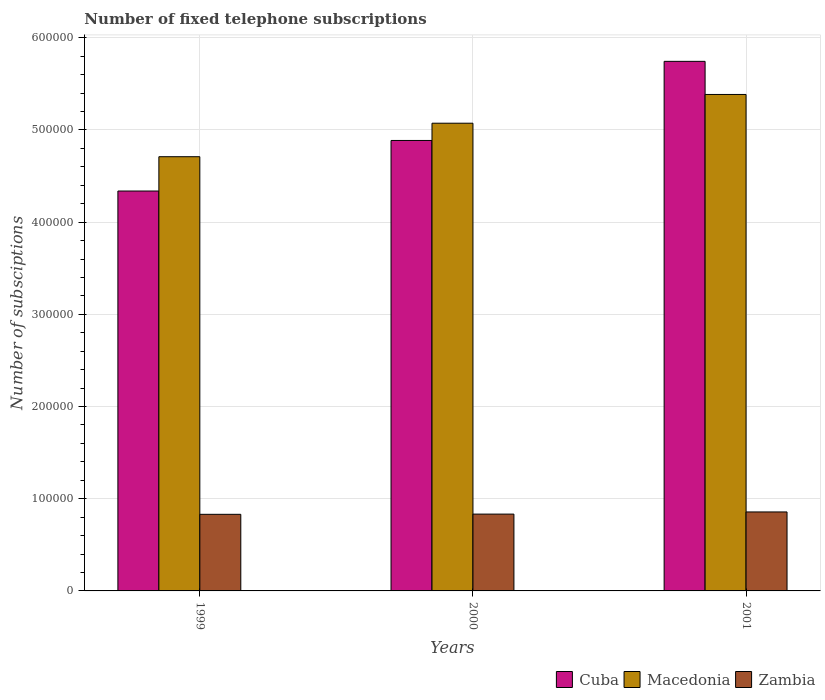Are the number of bars per tick equal to the number of legend labels?
Make the answer very short. Yes. How many bars are there on the 1st tick from the left?
Offer a very short reply. 3. What is the number of fixed telephone subscriptions in Macedonia in 2001?
Ensure brevity in your answer.  5.39e+05. Across all years, what is the maximum number of fixed telephone subscriptions in Cuba?
Provide a short and direct response. 5.74e+05. Across all years, what is the minimum number of fixed telephone subscriptions in Zambia?
Give a very brief answer. 8.31e+04. What is the total number of fixed telephone subscriptions in Macedonia in the graph?
Your answer should be very brief. 1.52e+06. What is the difference between the number of fixed telephone subscriptions in Cuba in 1999 and that in 2000?
Provide a short and direct response. -5.48e+04. What is the difference between the number of fixed telephone subscriptions in Zambia in 2000 and the number of fixed telephone subscriptions in Cuba in 2001?
Ensure brevity in your answer.  -4.91e+05. What is the average number of fixed telephone subscriptions in Zambia per year?
Offer a very short reply. 8.40e+04. In the year 2000, what is the difference between the number of fixed telephone subscriptions in Cuba and number of fixed telephone subscriptions in Macedonia?
Keep it short and to the point. -1.87e+04. What is the ratio of the number of fixed telephone subscriptions in Macedonia in 2000 to that in 2001?
Your answer should be compact. 0.94. Is the number of fixed telephone subscriptions in Cuba in 2000 less than that in 2001?
Ensure brevity in your answer.  Yes. What is the difference between the highest and the second highest number of fixed telephone subscriptions in Zambia?
Offer a very short reply. 2336. What is the difference between the highest and the lowest number of fixed telephone subscriptions in Zambia?
Your response must be concise. 2578. Is the sum of the number of fixed telephone subscriptions in Macedonia in 1999 and 2001 greater than the maximum number of fixed telephone subscriptions in Cuba across all years?
Make the answer very short. Yes. What does the 2nd bar from the left in 2001 represents?
Your answer should be very brief. Macedonia. What does the 1st bar from the right in 2001 represents?
Offer a terse response. Zambia. How many bars are there?
Offer a terse response. 9. What is the difference between two consecutive major ticks on the Y-axis?
Your answer should be compact. 1.00e+05. Does the graph contain grids?
Provide a short and direct response. Yes. How many legend labels are there?
Make the answer very short. 3. What is the title of the graph?
Your response must be concise. Number of fixed telephone subscriptions. What is the label or title of the Y-axis?
Offer a terse response. Number of subsciptions. What is the Number of subsciptions in Cuba in 1999?
Provide a succinct answer. 4.34e+05. What is the Number of subsciptions of Macedonia in 1999?
Your answer should be very brief. 4.71e+05. What is the Number of subsciptions of Zambia in 1999?
Give a very brief answer. 8.31e+04. What is the Number of subsciptions of Cuba in 2000?
Provide a short and direct response. 4.89e+05. What is the Number of subsciptions of Macedonia in 2000?
Offer a very short reply. 5.07e+05. What is the Number of subsciptions in Zambia in 2000?
Your response must be concise. 8.33e+04. What is the Number of subsciptions in Cuba in 2001?
Offer a very short reply. 5.74e+05. What is the Number of subsciptions in Macedonia in 2001?
Ensure brevity in your answer.  5.39e+05. What is the Number of subsciptions of Zambia in 2001?
Your response must be concise. 8.57e+04. Across all years, what is the maximum Number of subsciptions of Cuba?
Make the answer very short. 5.74e+05. Across all years, what is the maximum Number of subsciptions in Macedonia?
Provide a short and direct response. 5.39e+05. Across all years, what is the maximum Number of subsciptions of Zambia?
Provide a short and direct response. 8.57e+04. Across all years, what is the minimum Number of subsciptions of Cuba?
Your response must be concise. 4.34e+05. Across all years, what is the minimum Number of subsciptions of Macedonia?
Provide a short and direct response. 4.71e+05. Across all years, what is the minimum Number of subsciptions in Zambia?
Your answer should be very brief. 8.31e+04. What is the total Number of subsciptions of Cuba in the graph?
Give a very brief answer. 1.50e+06. What is the total Number of subsciptions in Macedonia in the graph?
Provide a short and direct response. 1.52e+06. What is the total Number of subsciptions in Zambia in the graph?
Provide a short and direct response. 2.52e+05. What is the difference between the Number of subsciptions in Cuba in 1999 and that in 2000?
Your answer should be very brief. -5.48e+04. What is the difference between the Number of subsciptions of Macedonia in 1999 and that in 2000?
Offer a very short reply. -3.63e+04. What is the difference between the Number of subsciptions in Zambia in 1999 and that in 2000?
Keep it short and to the point. -242. What is the difference between the Number of subsciptions in Cuba in 1999 and that in 2001?
Ensure brevity in your answer.  -1.41e+05. What is the difference between the Number of subsciptions in Macedonia in 1999 and that in 2001?
Ensure brevity in your answer.  -6.75e+04. What is the difference between the Number of subsciptions in Zambia in 1999 and that in 2001?
Your answer should be very brief. -2578. What is the difference between the Number of subsciptions of Cuba in 2000 and that in 2001?
Make the answer very short. -8.58e+04. What is the difference between the Number of subsciptions in Macedonia in 2000 and that in 2001?
Your answer should be compact. -3.12e+04. What is the difference between the Number of subsciptions of Zambia in 2000 and that in 2001?
Provide a short and direct response. -2336. What is the difference between the Number of subsciptions in Cuba in 1999 and the Number of subsciptions in Macedonia in 2000?
Give a very brief answer. -7.36e+04. What is the difference between the Number of subsciptions in Cuba in 1999 and the Number of subsciptions in Zambia in 2000?
Offer a terse response. 3.50e+05. What is the difference between the Number of subsciptions of Macedonia in 1999 and the Number of subsciptions of Zambia in 2000?
Offer a terse response. 3.88e+05. What is the difference between the Number of subsciptions of Cuba in 1999 and the Number of subsciptions of Macedonia in 2001?
Give a very brief answer. -1.05e+05. What is the difference between the Number of subsciptions in Cuba in 1999 and the Number of subsciptions in Zambia in 2001?
Offer a terse response. 3.48e+05. What is the difference between the Number of subsciptions in Macedonia in 1999 and the Number of subsciptions in Zambia in 2001?
Your response must be concise. 3.85e+05. What is the difference between the Number of subsciptions in Cuba in 2000 and the Number of subsciptions in Macedonia in 2001?
Give a very brief answer. -4.99e+04. What is the difference between the Number of subsciptions of Cuba in 2000 and the Number of subsciptions of Zambia in 2001?
Provide a succinct answer. 4.03e+05. What is the difference between the Number of subsciptions of Macedonia in 2000 and the Number of subsciptions of Zambia in 2001?
Ensure brevity in your answer.  4.22e+05. What is the average Number of subsciptions of Cuba per year?
Make the answer very short. 4.99e+05. What is the average Number of subsciptions in Macedonia per year?
Make the answer very short. 5.06e+05. What is the average Number of subsciptions in Zambia per year?
Provide a short and direct response. 8.40e+04. In the year 1999, what is the difference between the Number of subsciptions in Cuba and Number of subsciptions in Macedonia?
Your answer should be compact. -3.72e+04. In the year 1999, what is the difference between the Number of subsciptions of Cuba and Number of subsciptions of Zambia?
Make the answer very short. 3.51e+05. In the year 1999, what is the difference between the Number of subsciptions of Macedonia and Number of subsciptions of Zambia?
Provide a succinct answer. 3.88e+05. In the year 2000, what is the difference between the Number of subsciptions of Cuba and Number of subsciptions of Macedonia?
Keep it short and to the point. -1.87e+04. In the year 2000, what is the difference between the Number of subsciptions of Cuba and Number of subsciptions of Zambia?
Provide a short and direct response. 4.05e+05. In the year 2000, what is the difference between the Number of subsciptions in Macedonia and Number of subsciptions in Zambia?
Offer a terse response. 4.24e+05. In the year 2001, what is the difference between the Number of subsciptions of Cuba and Number of subsciptions of Macedonia?
Provide a short and direct response. 3.59e+04. In the year 2001, what is the difference between the Number of subsciptions in Cuba and Number of subsciptions in Zambia?
Your answer should be compact. 4.89e+05. In the year 2001, what is the difference between the Number of subsciptions of Macedonia and Number of subsciptions of Zambia?
Provide a short and direct response. 4.53e+05. What is the ratio of the Number of subsciptions in Cuba in 1999 to that in 2000?
Your answer should be compact. 0.89. What is the ratio of the Number of subsciptions in Macedonia in 1999 to that in 2000?
Offer a very short reply. 0.93. What is the ratio of the Number of subsciptions of Cuba in 1999 to that in 2001?
Keep it short and to the point. 0.76. What is the ratio of the Number of subsciptions of Macedonia in 1999 to that in 2001?
Offer a terse response. 0.87. What is the ratio of the Number of subsciptions of Zambia in 1999 to that in 2001?
Keep it short and to the point. 0.97. What is the ratio of the Number of subsciptions in Cuba in 2000 to that in 2001?
Give a very brief answer. 0.85. What is the ratio of the Number of subsciptions in Macedonia in 2000 to that in 2001?
Make the answer very short. 0.94. What is the ratio of the Number of subsciptions of Zambia in 2000 to that in 2001?
Your answer should be very brief. 0.97. What is the difference between the highest and the second highest Number of subsciptions in Cuba?
Offer a very short reply. 8.58e+04. What is the difference between the highest and the second highest Number of subsciptions in Macedonia?
Provide a succinct answer. 3.12e+04. What is the difference between the highest and the second highest Number of subsciptions in Zambia?
Offer a terse response. 2336. What is the difference between the highest and the lowest Number of subsciptions of Cuba?
Provide a short and direct response. 1.41e+05. What is the difference between the highest and the lowest Number of subsciptions in Macedonia?
Provide a succinct answer. 6.75e+04. What is the difference between the highest and the lowest Number of subsciptions in Zambia?
Your answer should be compact. 2578. 